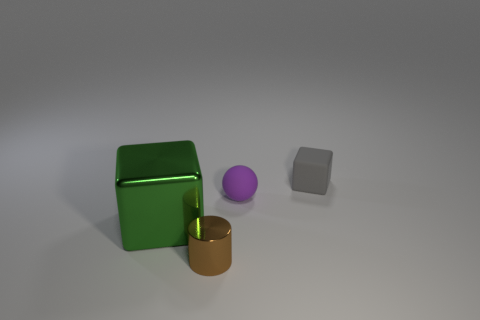Can you guess what the purpose of these objects might be? The objects in the image appear to be simplistic geometric shapes and do not seem to have a specific purpose beyond perhaps being used as teaching aids for geometry or as part of a visual composition in art. The different sizes, shapes, and colors could be useful for educational demonstrations or stylistic arrangements. 